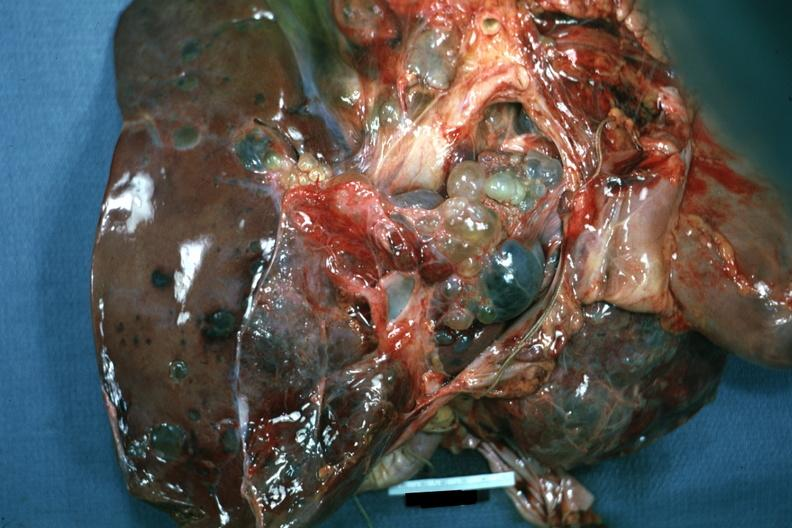what does this image show?
Answer the question using a single word or phrase. Case of polycystic disease lesions seen from external 